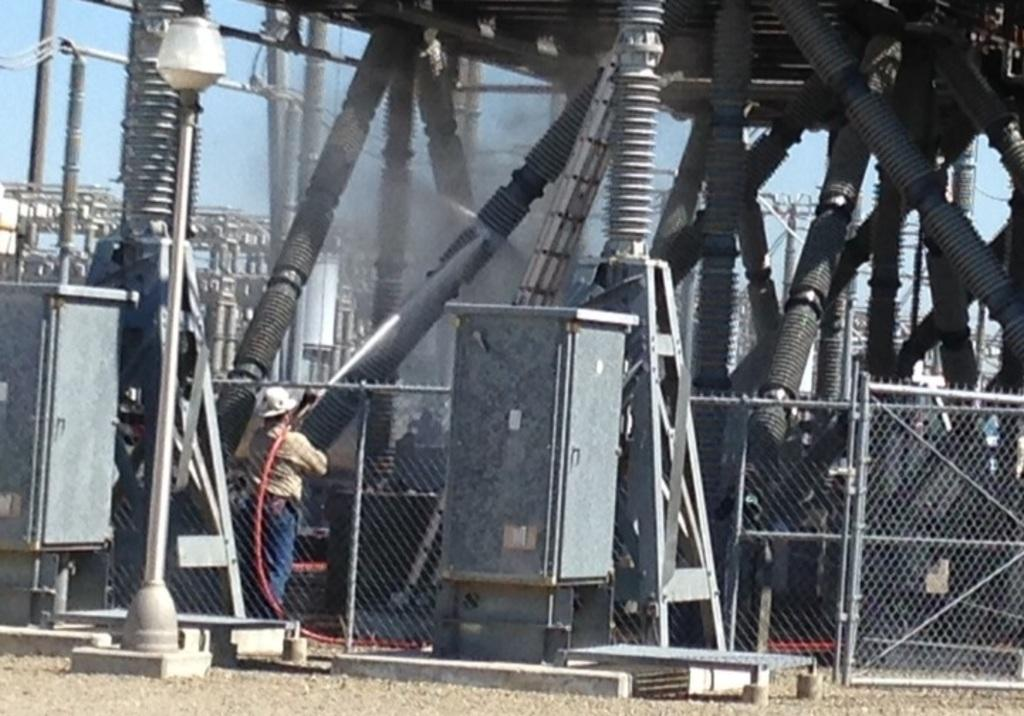What type of structure is present in the image? There is an electricity substation in the image. Can you describe any other elements in the image? There is a person and boxes visible in the image. What type of barrier is present in the image? There is a fence in the image. What can be seen in the background of the image? The sky is visible in the background of the image. How many dolls are sitting on the fence in the image? There are no dolls present in the image; it features an electricity substation, a person, boxes, and a fence. Can you hear the bell ringing in the image? There is no bell present in the image, so it cannot be heard. 